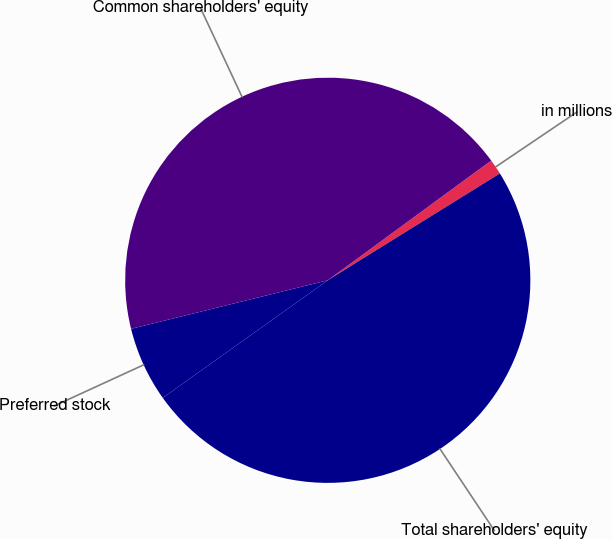Convert chart to OTSL. <chart><loc_0><loc_0><loc_500><loc_500><pie_chart><fcel>in millions<fcel>Total shareholders' equity<fcel>Preferred stock<fcel>Common shareholders' equity<nl><fcel>1.22%<fcel>48.99%<fcel>6.0%<fcel>43.79%<nl></chart> 